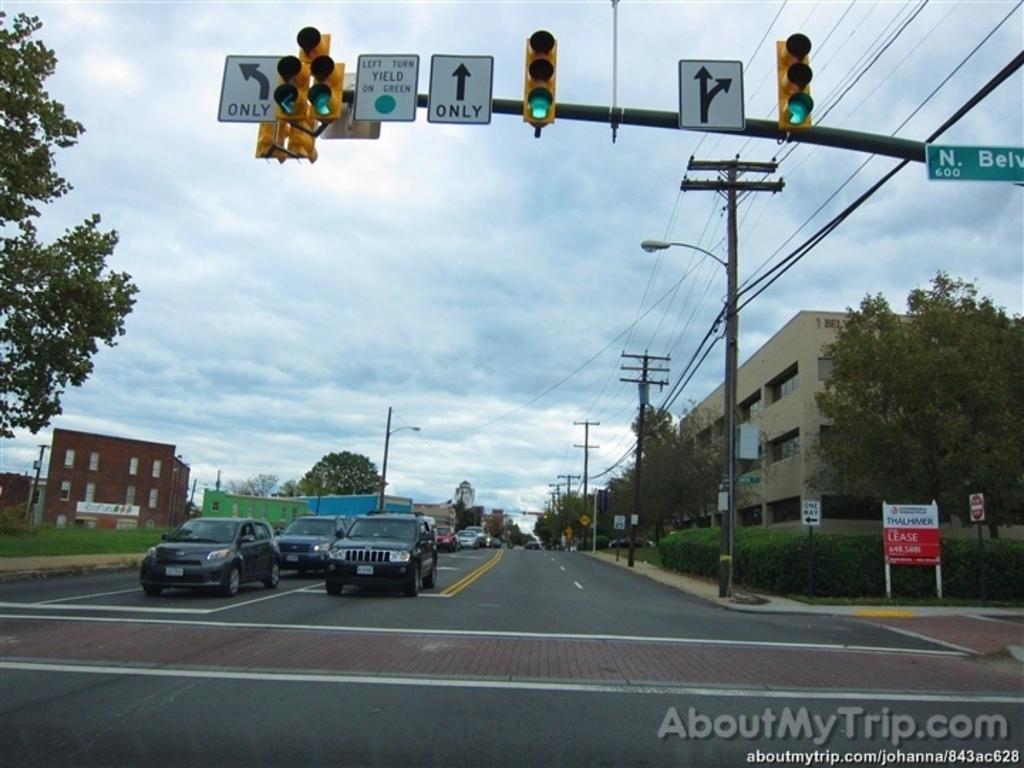Please provide a concise description of this image. In this image there are signal lights, boards, poles, lights, trees, grass, road, plants, vehicles, buildings and objects. In the background of the image there is a cloudy sky. At the bottom of the image there is a watermark.  